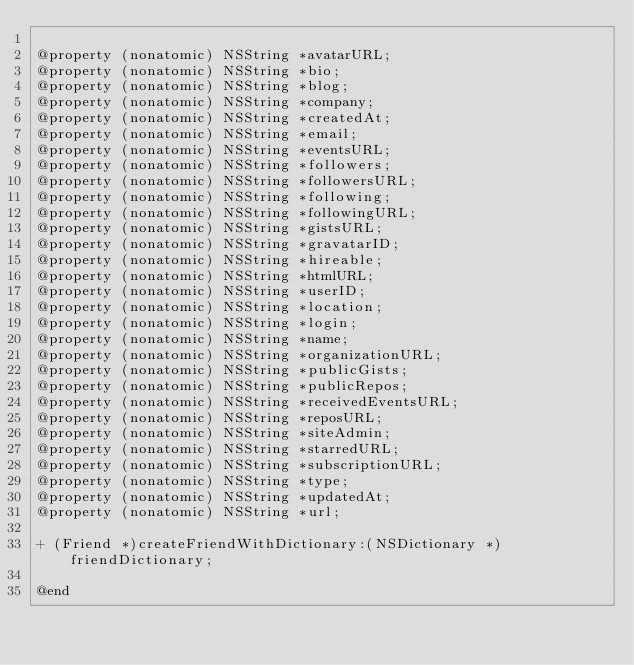Convert code to text. <code><loc_0><loc_0><loc_500><loc_500><_C_>
@property (nonatomic) NSString *avatarURL;
@property (nonatomic) NSString *bio;
@property (nonatomic) NSString *blog;
@property (nonatomic) NSString *company;
@property (nonatomic) NSString *createdAt;
@property (nonatomic) NSString *email;
@property (nonatomic) NSString *eventsURL;
@property (nonatomic) NSString *followers;
@property (nonatomic) NSString *followersURL;
@property (nonatomic) NSString *following;
@property (nonatomic) NSString *followingURL;
@property (nonatomic) NSString *gistsURL;
@property (nonatomic) NSString *gravatarID;
@property (nonatomic) NSString *hireable;
@property (nonatomic) NSString *htmlURL;
@property (nonatomic) NSString *userID;
@property (nonatomic) NSString *location;
@property (nonatomic) NSString *login;
@property (nonatomic) NSString *name;
@property (nonatomic) NSString *organizationURL;
@property (nonatomic) NSString *publicGists;
@property (nonatomic) NSString *publicRepos;
@property (nonatomic) NSString *receivedEventsURL;
@property (nonatomic) NSString *reposURL;
@property (nonatomic) NSString *siteAdmin;
@property (nonatomic) NSString *starredURL;
@property (nonatomic) NSString *subscriptionURL;
@property (nonatomic) NSString *type;
@property (nonatomic) NSString *updatedAt;
@property (nonatomic) NSString *url;

+ (Friend *)createFriendWithDictionary:(NSDictionary *)friendDictionary;

@end
</code> 